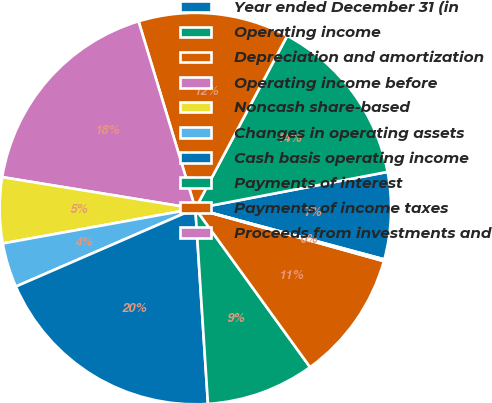Convert chart. <chart><loc_0><loc_0><loc_500><loc_500><pie_chart><fcel>Year ended December 31 (in<fcel>Operating income<fcel>Depreciation and amortization<fcel>Operating income before<fcel>Noncash share-based<fcel>Changes in operating assets<fcel>Cash basis operating income<fcel>Payments of interest<fcel>Payments of income taxes<fcel>Proceeds from investments and<nl><fcel>7.18%<fcel>14.22%<fcel>12.46%<fcel>17.74%<fcel>5.42%<fcel>3.67%<fcel>19.5%<fcel>8.94%<fcel>10.7%<fcel>0.15%<nl></chart> 